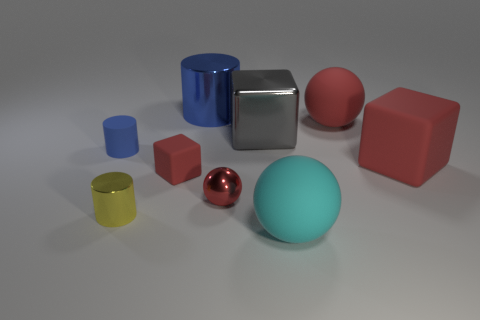Subtract all red matte balls. How many balls are left? 2 Add 1 big cyan rubber cylinders. How many objects exist? 10 Subtract all cylinders. How many objects are left? 6 Subtract all spheres. Subtract all tiny matte blocks. How many objects are left? 5 Add 7 tiny blue rubber objects. How many tiny blue rubber objects are left? 8 Add 5 big red matte cylinders. How many big red matte cylinders exist? 5 Subtract 0 brown cubes. How many objects are left? 9 